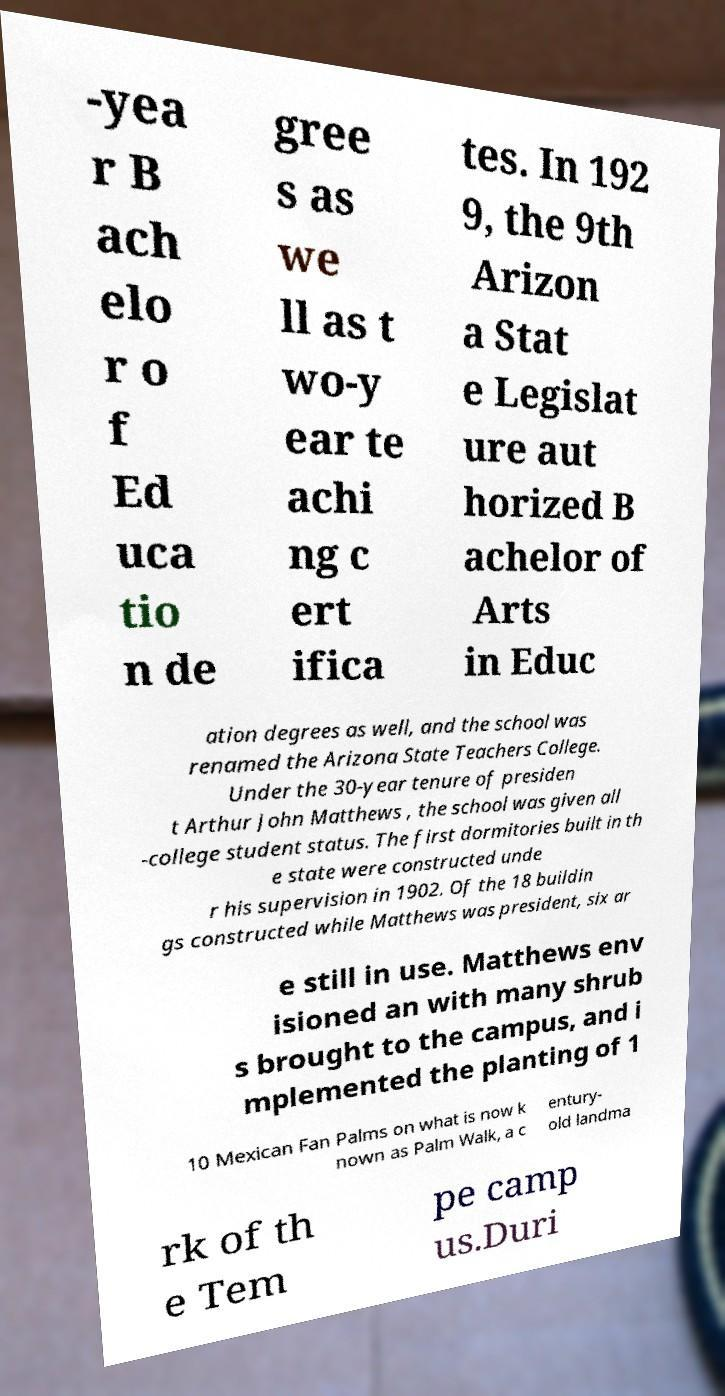Please identify and transcribe the text found in this image. -yea r B ach elo r o f Ed uca tio n de gree s as we ll as t wo-y ear te achi ng c ert ifica tes. In 192 9, the 9th Arizon a Stat e Legislat ure aut horized B achelor of Arts in Educ ation degrees as well, and the school was renamed the Arizona State Teachers College. Under the 30-year tenure of presiden t Arthur John Matthews , the school was given all -college student status. The first dormitories built in th e state were constructed unde r his supervision in 1902. Of the 18 buildin gs constructed while Matthews was president, six ar e still in use. Matthews env isioned an with many shrub s brought to the campus, and i mplemented the planting of 1 10 Mexican Fan Palms on what is now k nown as Palm Walk, a c entury- old landma rk of th e Tem pe camp us.Duri 